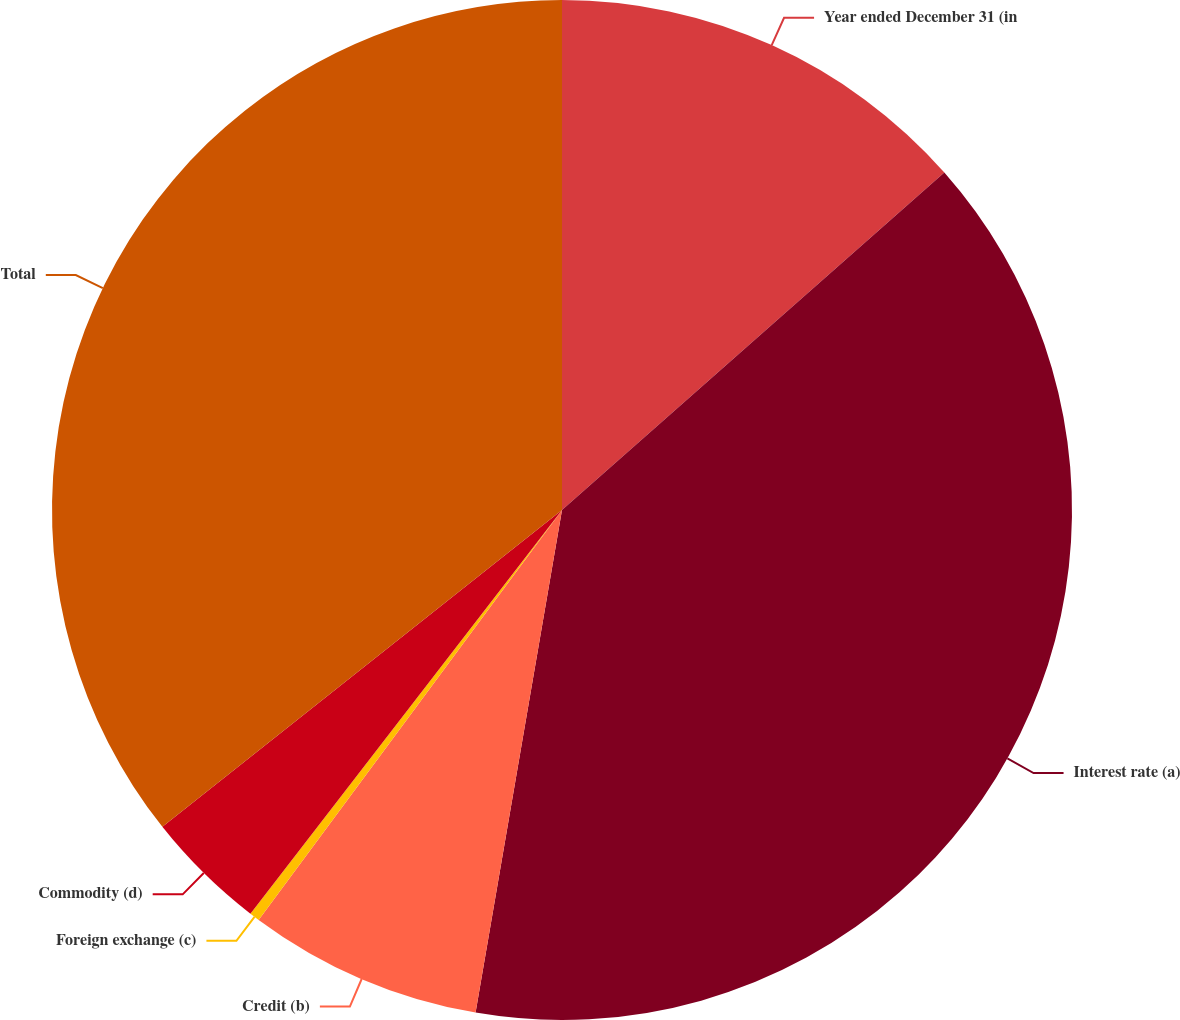<chart> <loc_0><loc_0><loc_500><loc_500><pie_chart><fcel>Year ended December 31 (in<fcel>Interest rate (a)<fcel>Credit (b)<fcel>Foreign exchange (c)<fcel>Commodity (d)<fcel>Total<nl><fcel>13.49%<fcel>39.22%<fcel>7.43%<fcel>0.32%<fcel>3.87%<fcel>35.67%<nl></chart> 